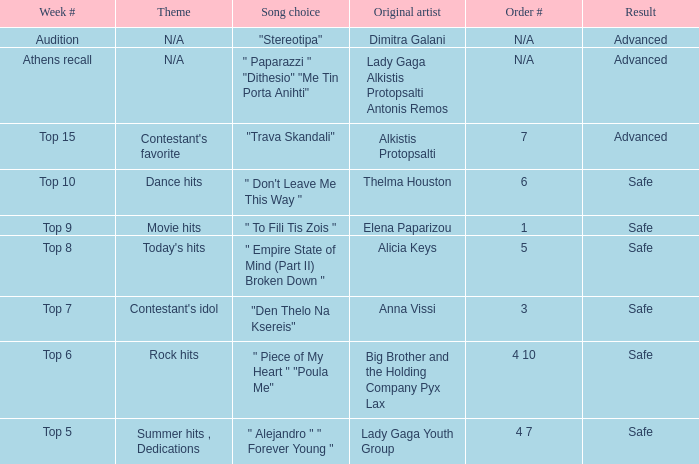Which artists have order figure 6? Thelma Houston. 